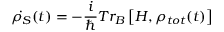<formula> <loc_0><loc_0><loc_500><loc_500>\dot { \rho _ { S } } ( t ) = - \frac { i } { } T { { r } _ { B } } \left [ H , { { \rho } _ { t o t } } ( t ) \right ]</formula> 